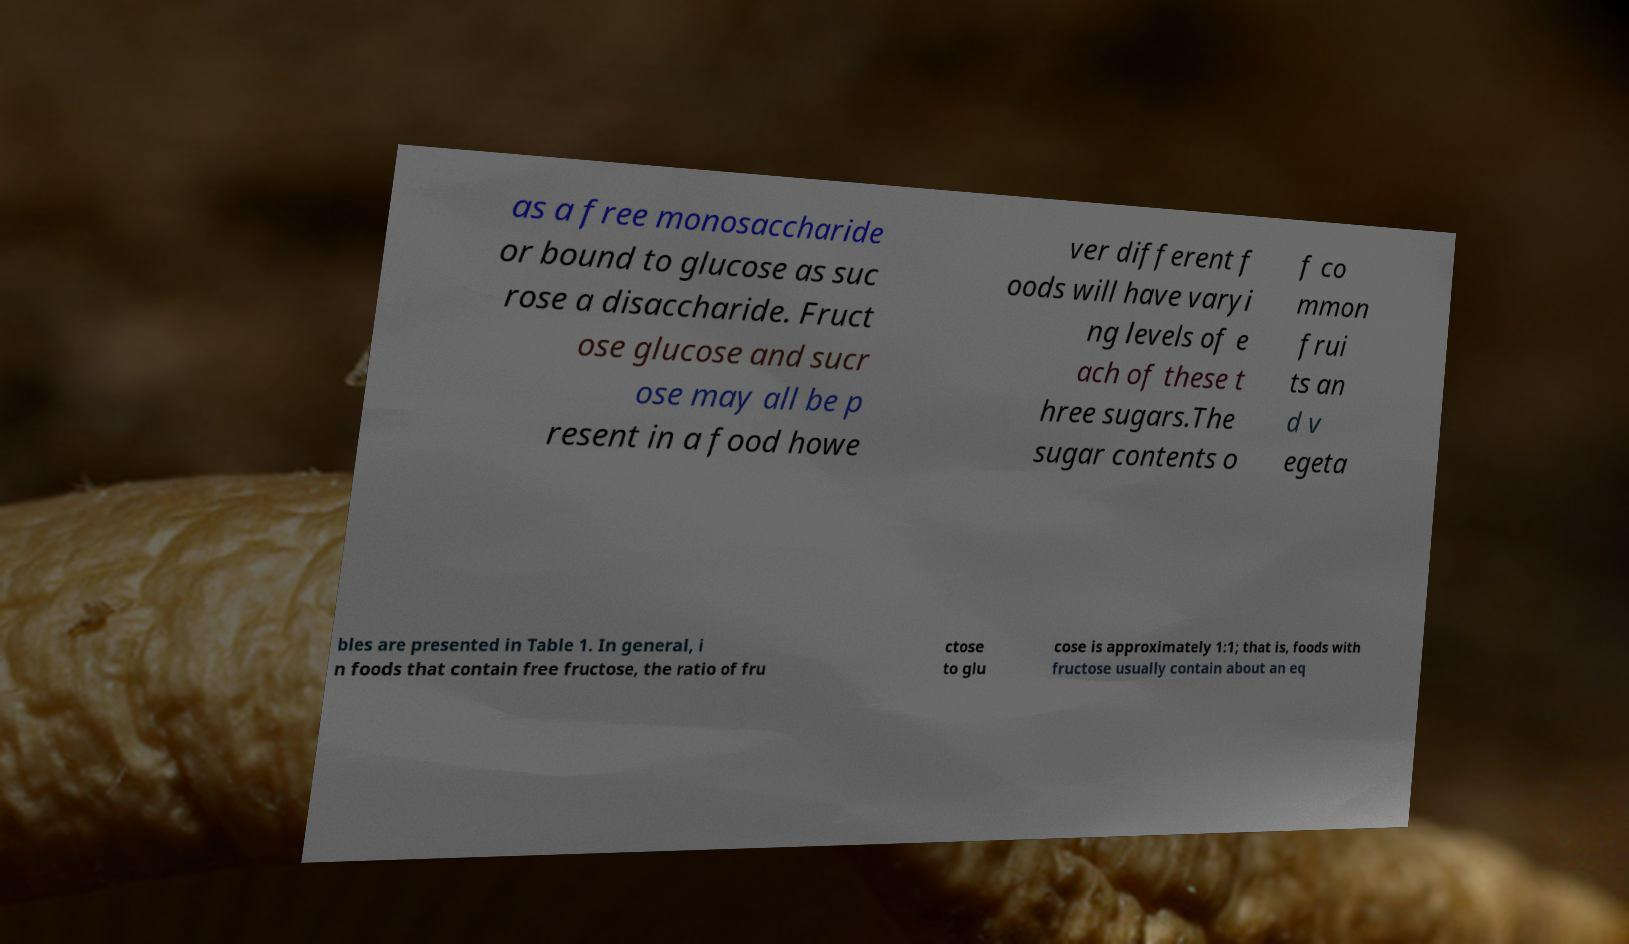Could you extract and type out the text from this image? as a free monosaccharide or bound to glucose as suc rose a disaccharide. Fruct ose glucose and sucr ose may all be p resent in a food howe ver different f oods will have varyi ng levels of e ach of these t hree sugars.The sugar contents o f co mmon frui ts an d v egeta bles are presented in Table 1. In general, i n foods that contain free fructose, the ratio of fru ctose to glu cose is approximately 1:1; that is, foods with fructose usually contain about an eq 